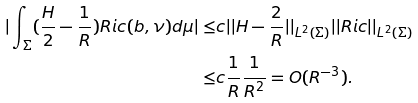<formula> <loc_0><loc_0><loc_500><loc_500>| \int _ { \Sigma } ( \frac { H } { 2 } - \frac { 1 } { R } ) R i c ( b , \nu ) d \mu | \leq & c | | H - \frac { 2 } { R } | | _ { L ^ { 2 } ( \Sigma ) } | | R i c | | _ { L ^ { 2 } ( \Sigma ) } \\ \leq & c \frac { 1 } { R } \frac { 1 } { R ^ { 2 } } = O ( R ^ { - 3 } ) .</formula> 